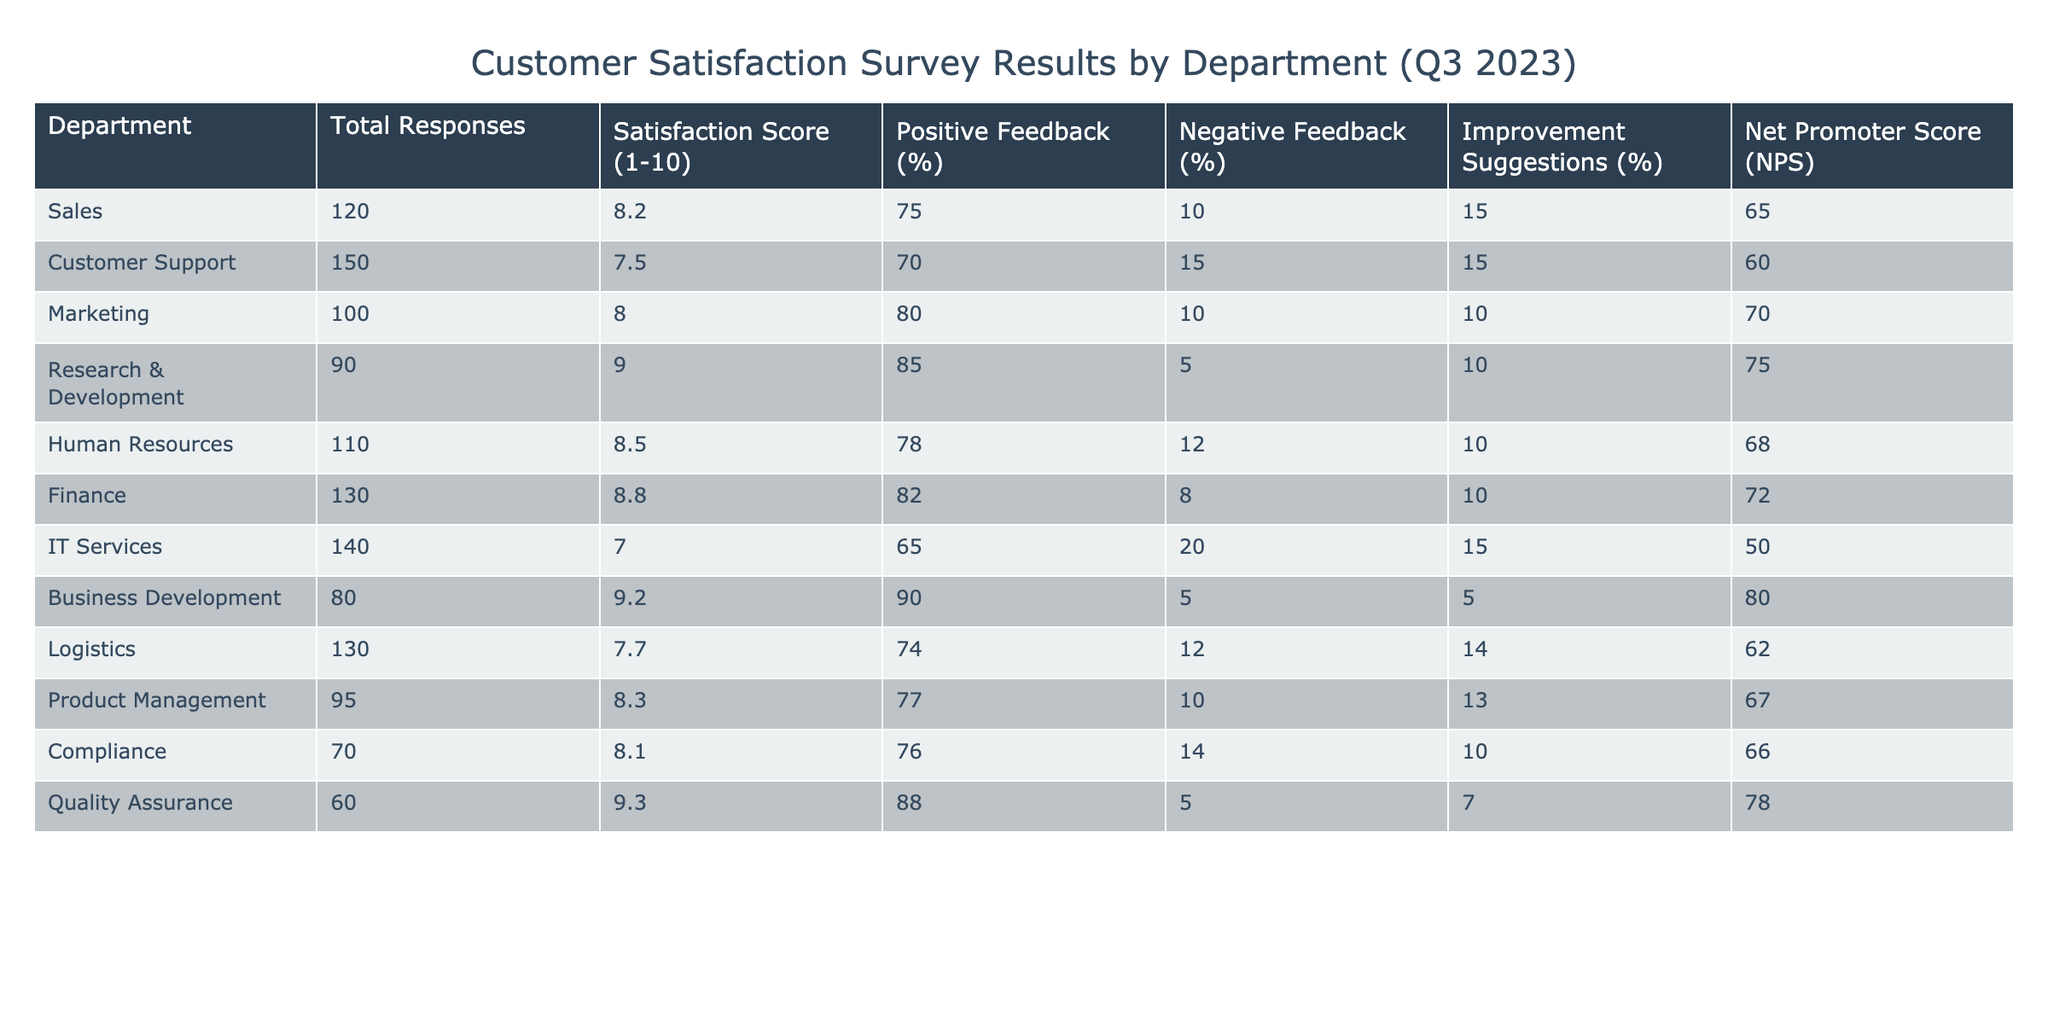What is the satisfaction score for the IT Services department? The satisfaction score for the IT Services department is directly listed in the table as 7.0.
Answer: 7.0 Which department received the highest net promoter score (NPS)? The highest NPS is 80, which belongs to the Business Development department, as indicated in the table.
Answer: Business Development How many total responses did the Customer Support department receive? The total responses for the Customer Support department are shown in the table as 150.
Answer: 150 What is the average satisfaction score of all departments? To find the average satisfaction score, we sum the scores (8.2 + 7.5 + 8.0 + 9.0 + 8.5 + 8.8 + 7.0 + 9.2 + 7.7 + 8.3 + 8.1 + 9.3) = 104.2 and divide by the number of departments (12), yielding an average of 104.2 / 12 = 8.68.
Answer: 8.68 Does the Finance department have a positive feedback percentage higher than 80%? The Finance department has a positive feedback percentage of 82%, which is indeed higher than 80%.
Answer: Yes What is the difference in satisfaction scores between the highest and lowest departments? The highest satisfaction score is from Research & Development at 9.0 and the lowest is from IT Services at 7.0. The difference is 9.0 - 7.0 = 2.0.
Answer: 2.0 Which department has the lowest percentage of positive feedback? The IT Services department has the lowest positive feedback percentage at 65%, as seen in the table.
Answer: IT Services What percentage of improvement suggestions did the Human Resources department receive? The table shows that the Human Resources department received 10% improvement suggestions.
Answer: 10% Is the Customer Support department's negative feedback percentage lower than the average negative feedback percentage across all departments? The average negative feedback percentage is (10 + 15 + 10 + 5 + 12 + 8 + 20 + 5 + 12 + 10 + 14 + 5) / 12 = 11.67. Customer Support's negative feedback is 15%, which is higher than the average.
Answer: No Which department had more positive feedback, Logistics or Customer Support? Logistics has 74% positive feedback and Customer Support has 70%. Since 74% is greater than 70%, Logistics has more positive feedback.
Answer: Logistics 